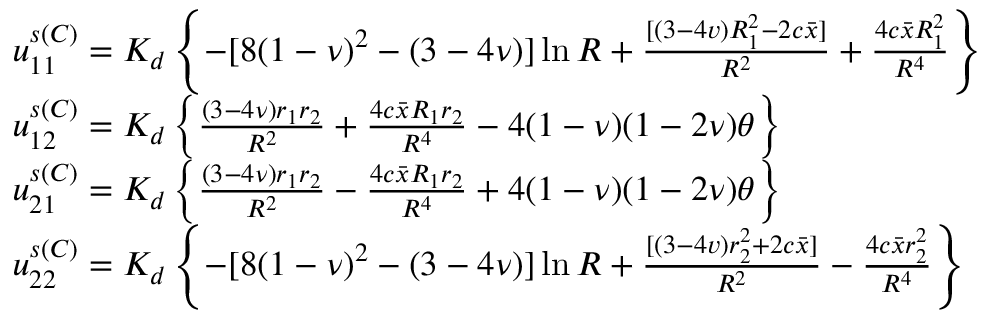Convert formula to latex. <formula><loc_0><loc_0><loc_500><loc_500>\begin{array} { r l } & { u _ { 1 1 } ^ { s ( C ) } = K _ { d } \left \{ - [ 8 ( 1 - \nu ) ^ { 2 } - ( 3 - 4 \nu ) ] \ln { R } + \frac { [ ( 3 - 4 v ) R _ { 1 } ^ { 2 } - 2 c \bar { x } ] } { R ^ { 2 } } + \frac { 4 c \bar { x } R _ { 1 } ^ { 2 } } { R ^ { 4 } } \right \} } \\ & { u _ { 1 2 } ^ { s ( C ) } = K _ { d } \left \{ \frac { ( 3 - 4 \nu ) r _ { 1 } r _ { 2 } } { R ^ { 2 } } + \frac { 4 c \bar { x } R _ { 1 } r _ { 2 } } { R ^ { 4 } } - 4 ( 1 - \nu ) ( 1 - 2 \nu ) \theta \right \} } \\ & { u _ { 2 1 } ^ { s ( C ) } = K _ { d } \left \{ \frac { ( 3 - 4 \nu ) r _ { 1 } r _ { 2 } } { R ^ { 2 } } - \frac { 4 c \bar { x } R _ { 1 } r _ { 2 } } { R ^ { 4 } } + 4 ( 1 - \nu ) ( 1 - 2 \nu ) \theta \right \} } \\ & { u _ { 2 2 } ^ { s ( C ) } = K _ { d } \left \{ - [ 8 ( 1 - \nu ) ^ { 2 } - ( 3 - 4 \nu ) ] \ln { R } + \frac { [ ( 3 - 4 v ) r _ { 2 } ^ { 2 } + 2 c \bar { x } ] } { R ^ { 2 } } - \frac { 4 c \bar { x } r _ { 2 } ^ { 2 } } { R ^ { 4 } } \right \} } \end{array}</formula> 